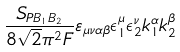<formula> <loc_0><loc_0><loc_500><loc_500>\frac { S _ { P B _ { 1 } B _ { 2 } } } { 8 \sqrt { 2 } \pi ^ { 2 } F } \varepsilon _ { \mu \nu \alpha \beta } \epsilon _ { 1 } ^ { \mu } \epsilon _ { 2 } ^ { \nu } k _ { 1 } ^ { \alpha } k _ { 2 } ^ { \beta }</formula> 